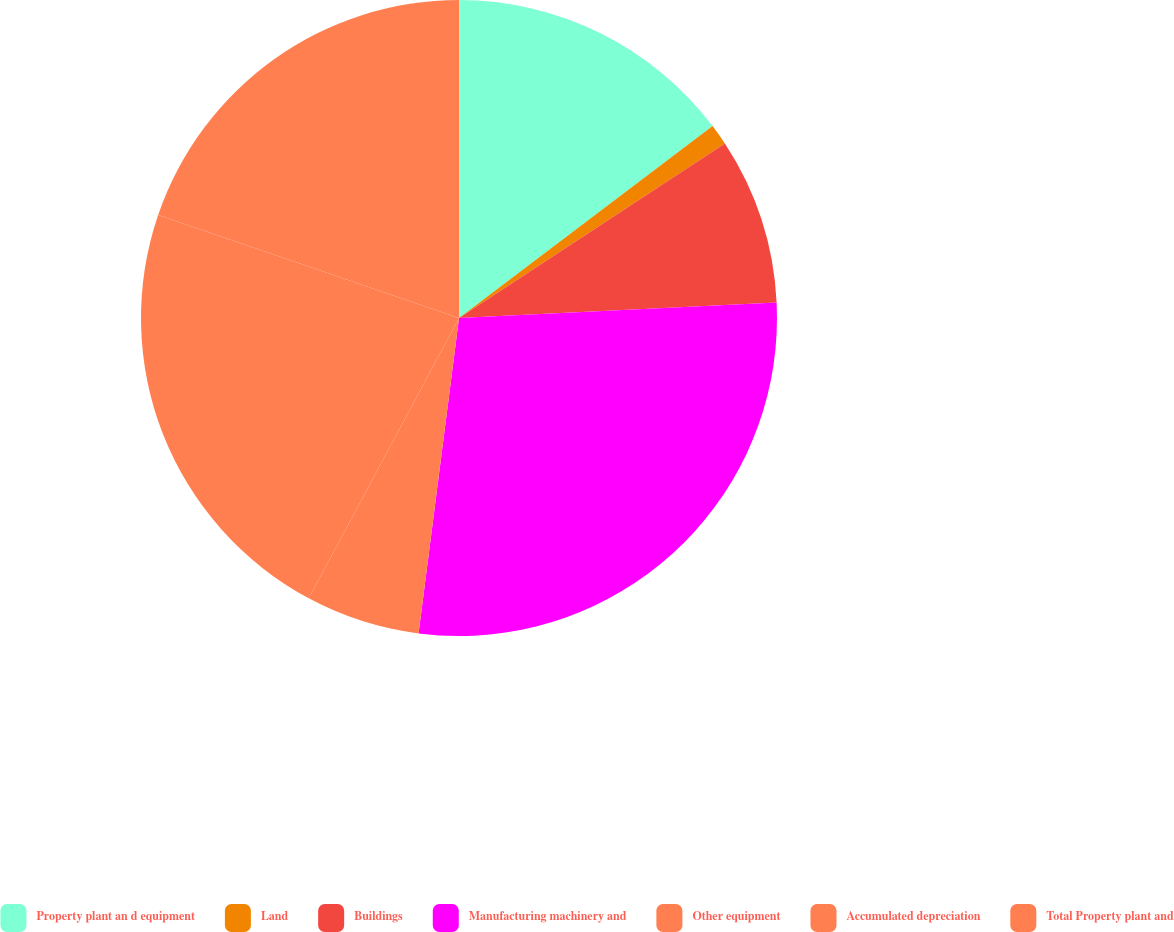<chart> <loc_0><loc_0><loc_500><loc_500><pie_chart><fcel>Property plant an d equipment<fcel>Land<fcel>Buildings<fcel>Manufacturing machinery and<fcel>Other equipment<fcel>Accumulated depreciation<fcel>Total Property plant and<nl><fcel>14.69%<fcel>1.07%<fcel>8.47%<fcel>27.8%<fcel>5.8%<fcel>22.42%<fcel>19.75%<nl></chart> 